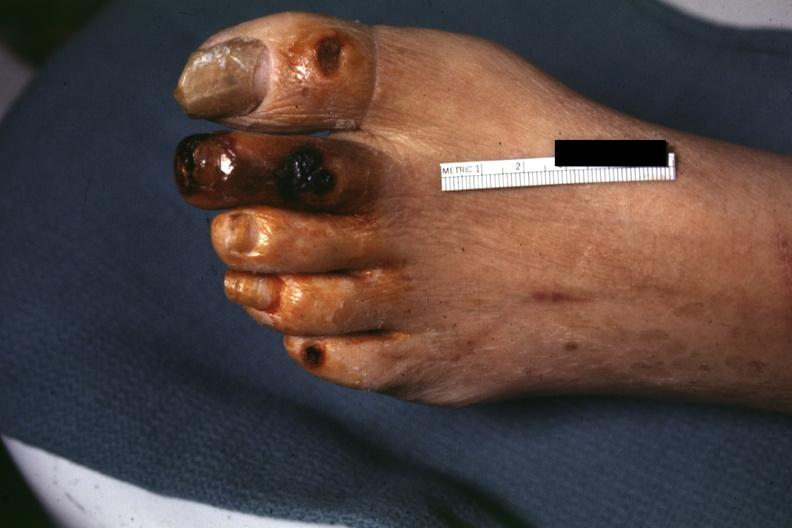what is present?
Answer the question using a single word or phrase. Foot 